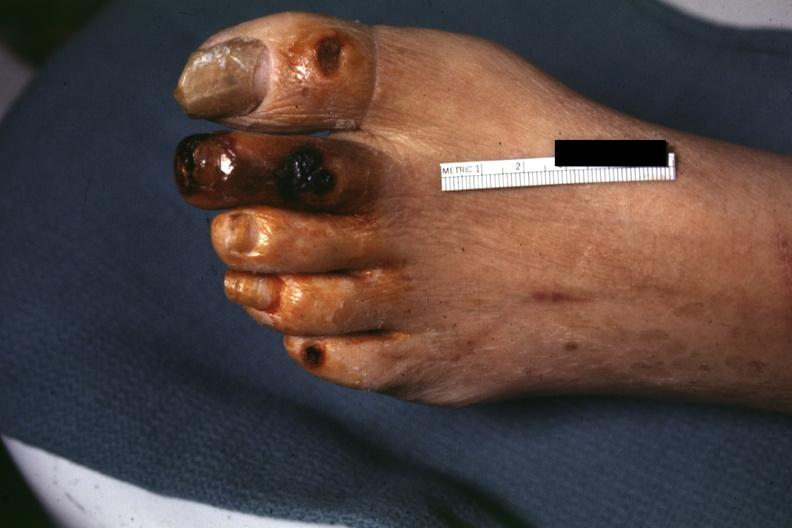what is present?
Answer the question using a single word or phrase. Foot 